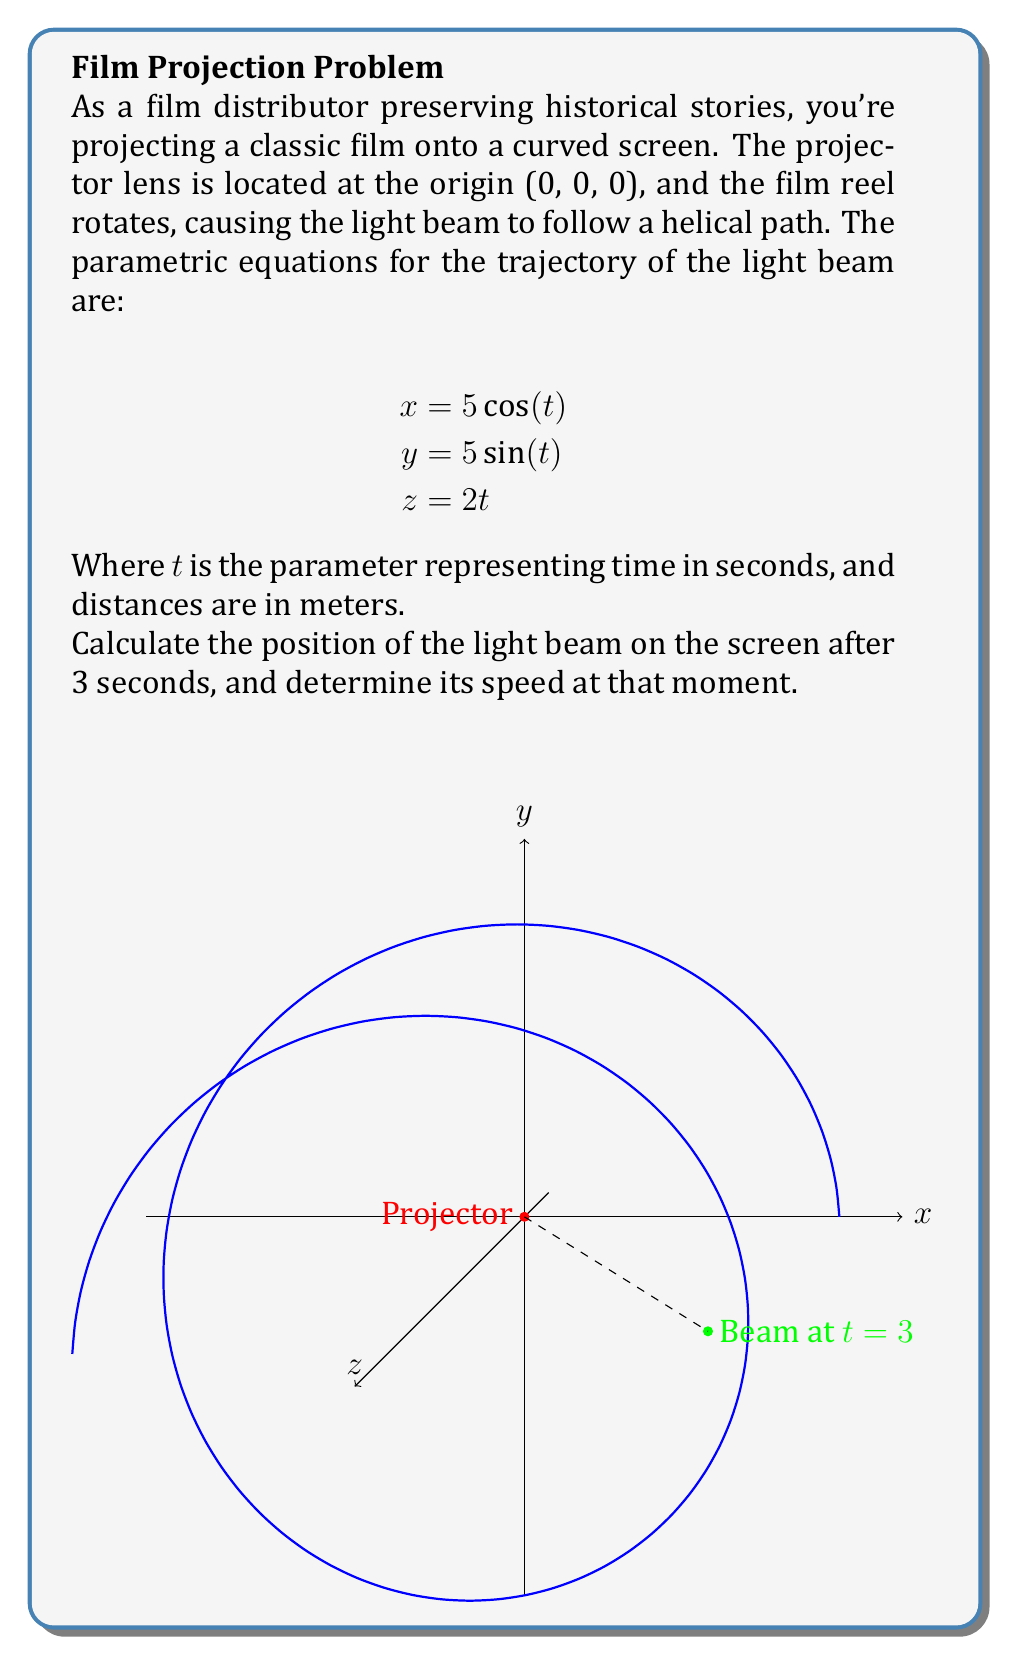Teach me how to tackle this problem. Let's approach this problem step-by-step:

1) Position at t = 3 seconds:
   Substitute t = 3 into the parametric equations:
   
   $x = 5\cos(3) \approx -4.15$ m
   $y = 5\sin(3) \approx 2.72$ m
   $z = 2(3) = 6$ m

2) To find the speed, we need to calculate the magnitude of the velocity vector:

   First, let's find the velocity components by differentiating the position equations:
   
   $\frac{dx}{dt} = -5\sin(t)$
   $\frac{dy}{dt} = 5\cos(t)$
   $\frac{dz}{dt} = 2$

3) At t = 3:
   
   $\frac{dx}{dt}|_{t=3} = -5\sin(3) \approx -2.72$ m/s
   $\frac{dy}{dt}|_{t=3} = 5\cos(3) \approx -4.15$ m/s
   $\frac{dz}{dt}|_{t=3} = 2$ m/s

4) The speed is the magnitude of the velocity vector:

   $$v = \sqrt{(\frac{dx}{dt})^2 + (\frac{dy}{dt})^2 + (\frac{dz}{dt})^2}$$
   
   $$v = \sqrt{(-2.72)^2 + (-4.15)^2 + 2^2}$$
   
   $$v = \sqrt{7.40 + 17.22 + 4} = \sqrt{28.62} \approx 5.35$$ m/s
Answer: Position: (-4.15, 2.72, 6) m; Speed: 5.35 m/s 